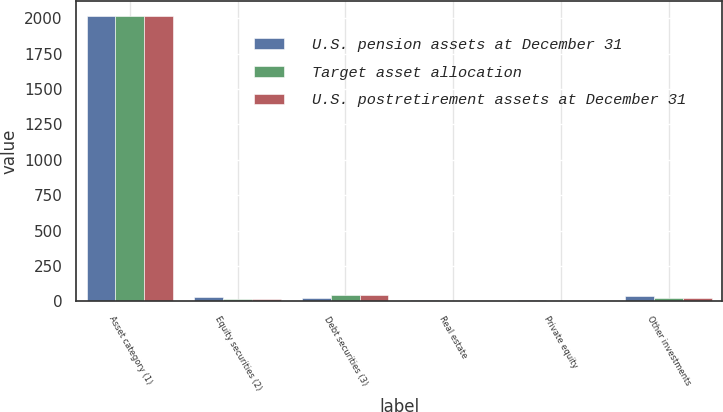Convert chart. <chart><loc_0><loc_0><loc_500><loc_500><stacked_bar_chart><ecel><fcel>Asset category (1)<fcel>Equity securities (2)<fcel>Debt securities (3)<fcel>Real estate<fcel>Private equity<fcel>Other investments<nl><fcel>U.S. pension assets at December 31<fcel>2018<fcel>30<fcel>24<fcel>10<fcel>12<fcel>37<nl><fcel>Target asset allocation<fcel>2017<fcel>20<fcel>48<fcel>5<fcel>3<fcel>24<nl><fcel>U.S. postretirement assets at December 31<fcel>2017<fcel>20<fcel>48<fcel>5<fcel>3<fcel>24<nl></chart> 